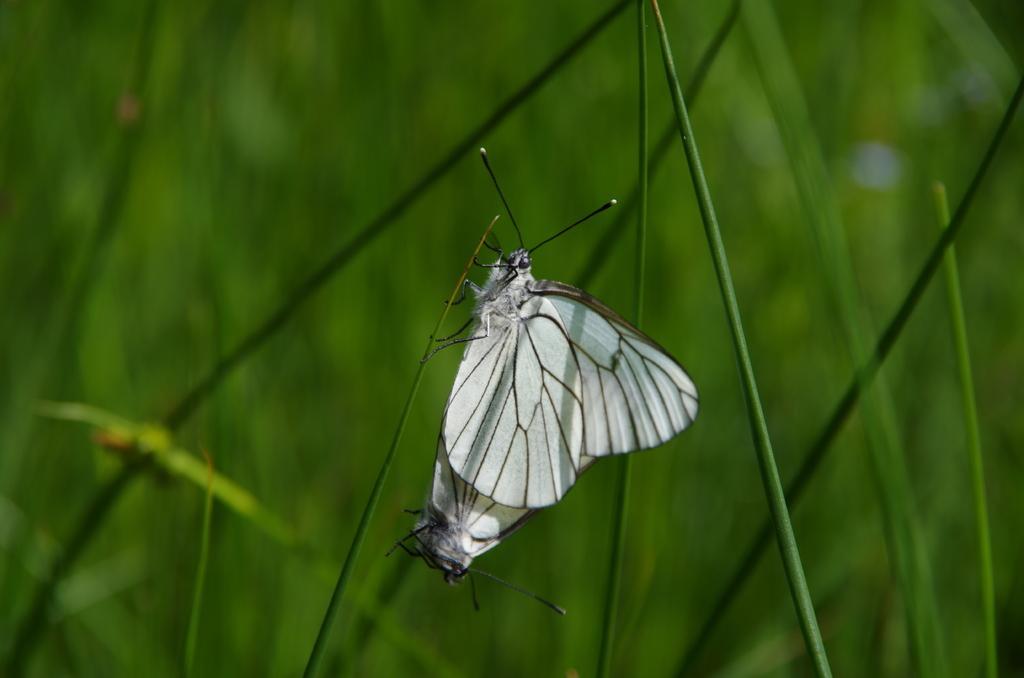Please provide a concise description of this image. In the center of the image, we can see a butterfly on the stem and in the background, there are plants. 